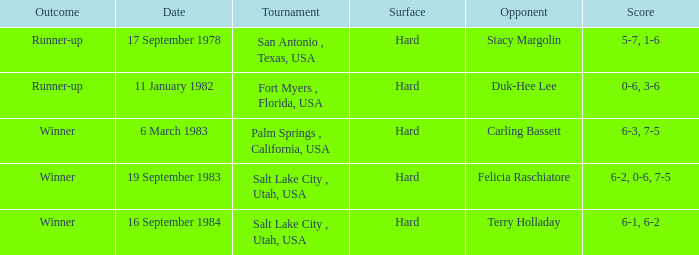What was the outcome of the match against Stacy Margolin? Runner-up. 